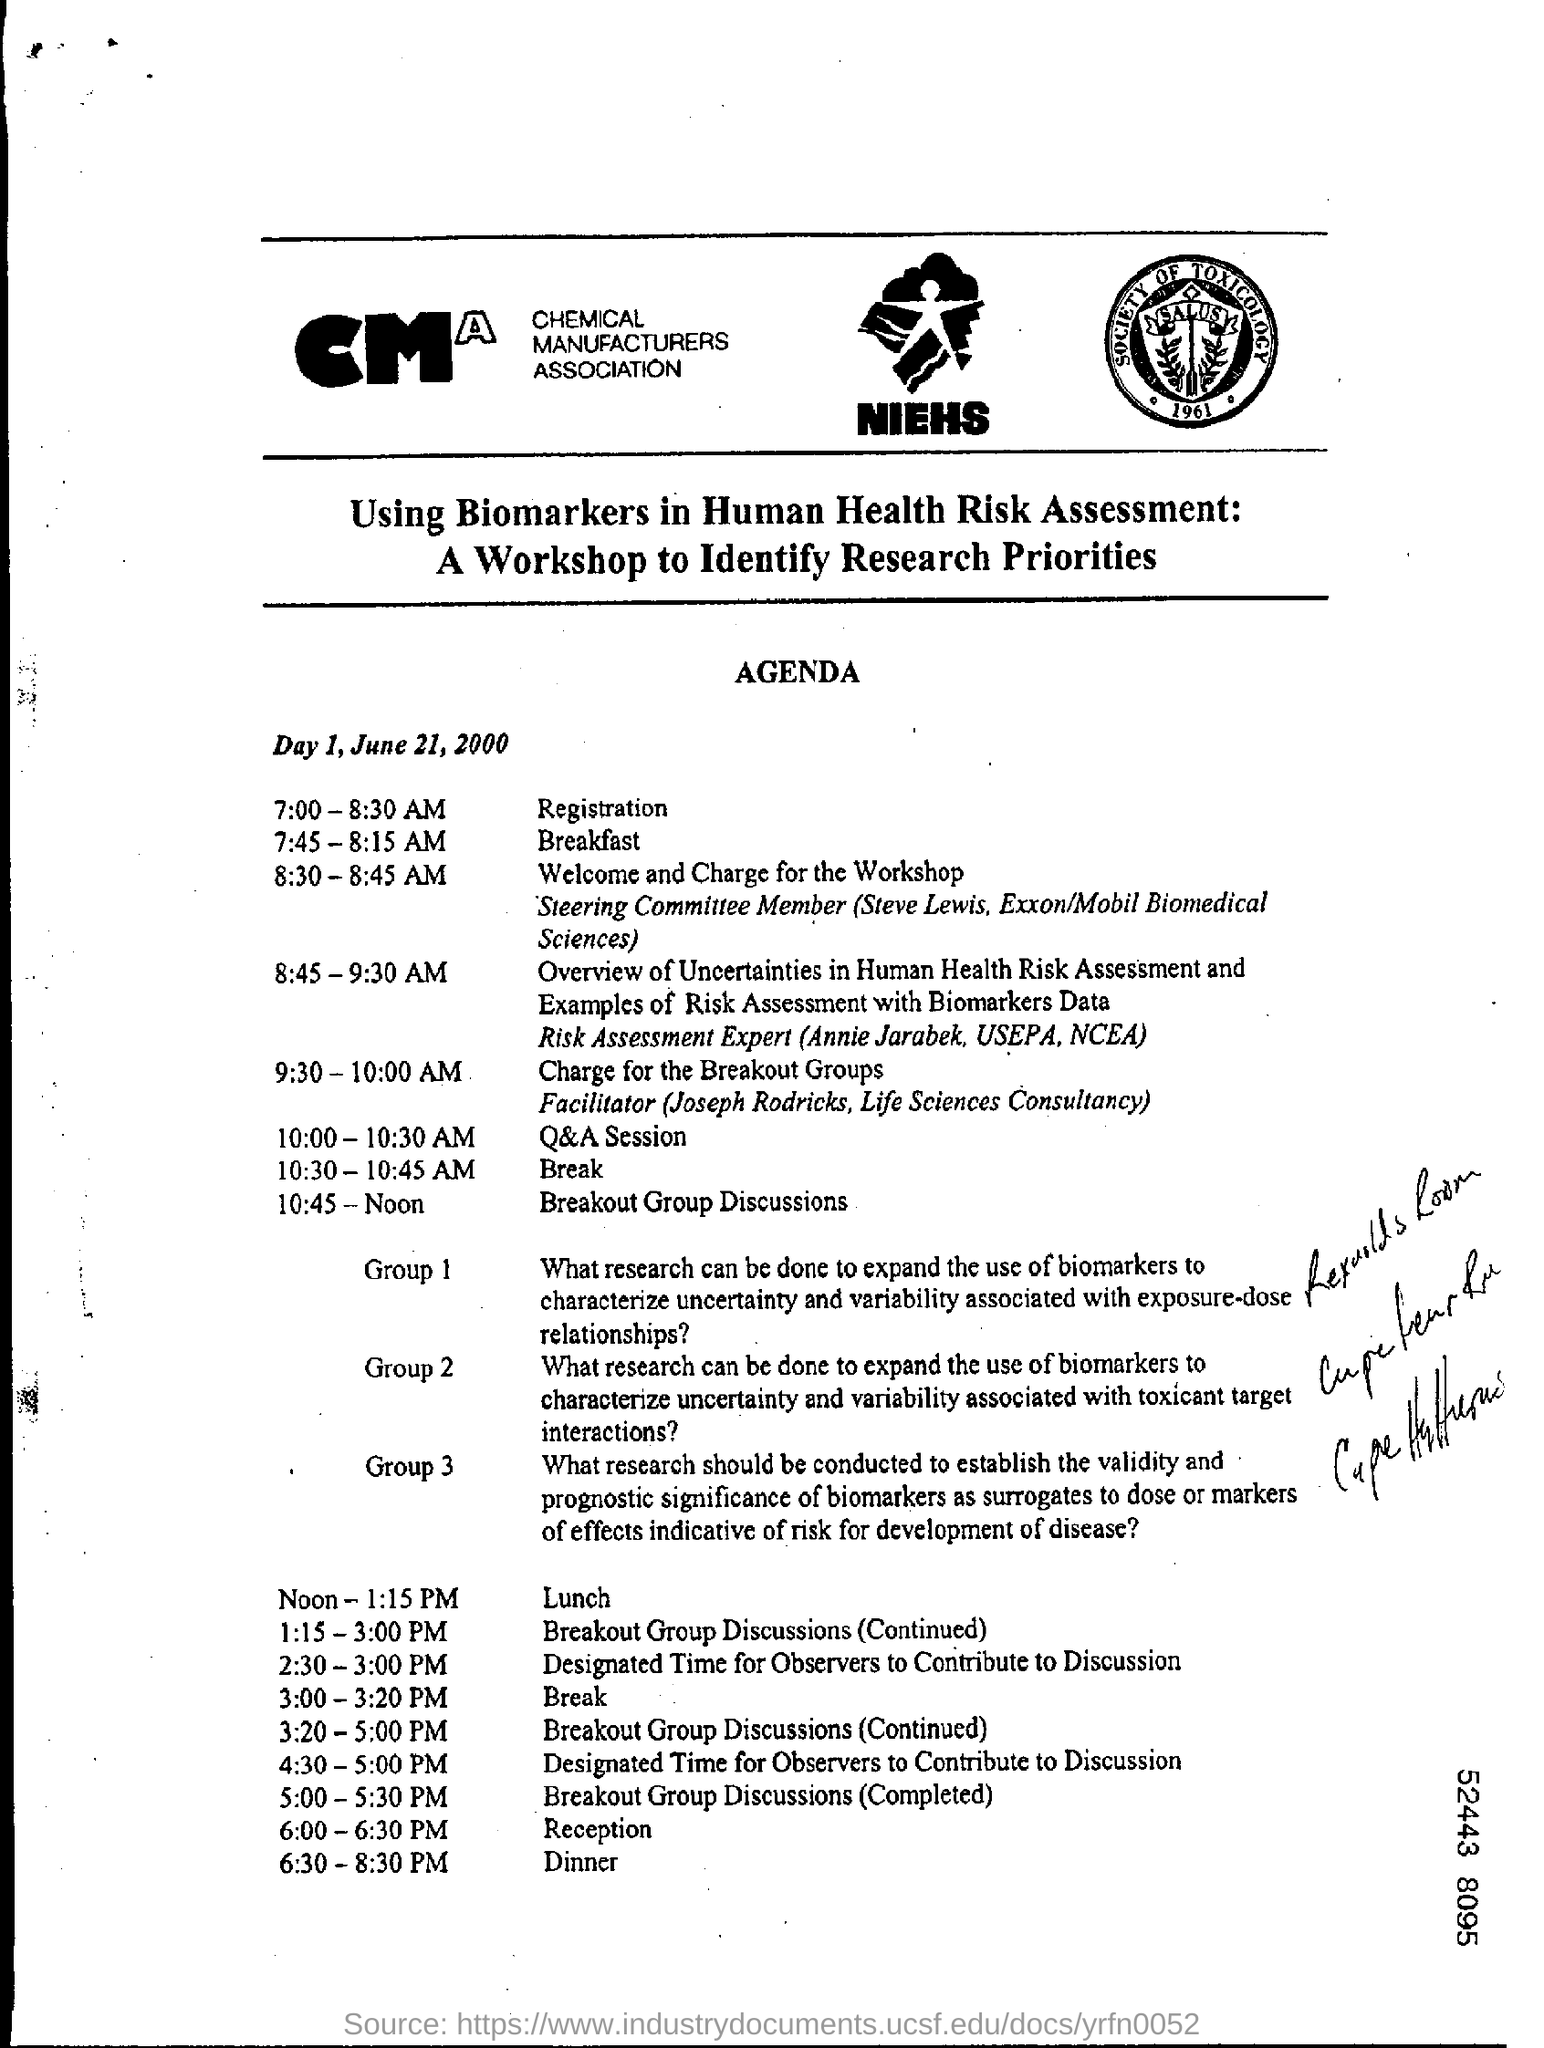What is the Time for Registration?
Offer a very short reply. 7:00 - 8:30 AM. What is the Time for Q&A Session?
Make the answer very short. 10:00 - 10:30 AM. What is the Time for Break?
Provide a short and direct response. 10:30 - 10:45 AM. What is the Time for Breakout Group Discussions?
Your response must be concise. 10:45 - Noon. What time is the Reception?
Provide a succinct answer. 6:00 - 6:30 PM. What is the Time for Breakfast?
Your answer should be compact. 7:45 - 8:15 AM. What is the Time for Dinner?
Make the answer very short. 6:30 -8:30 PM. 